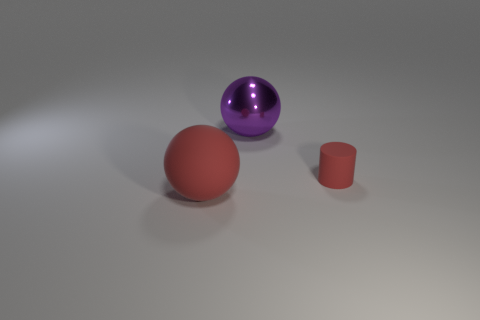Add 3 tiny matte cylinders. How many objects exist? 6 Subtract all spheres. How many objects are left? 1 Add 3 big balls. How many big balls exist? 5 Subtract 0 brown balls. How many objects are left? 3 Subtract all red cylinders. Subtract all big shiny objects. How many objects are left? 1 Add 2 purple things. How many purple things are left? 3 